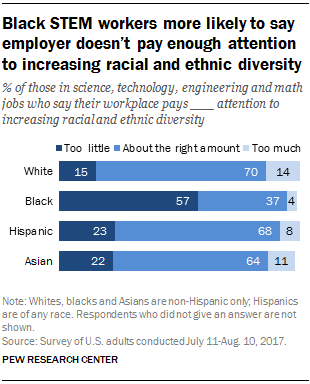Mention a couple of crucial points in this snapshot. The category is too little at 15, about the right amount at 70, and too much at 14. White. The ratio for black is 2.400740741... 